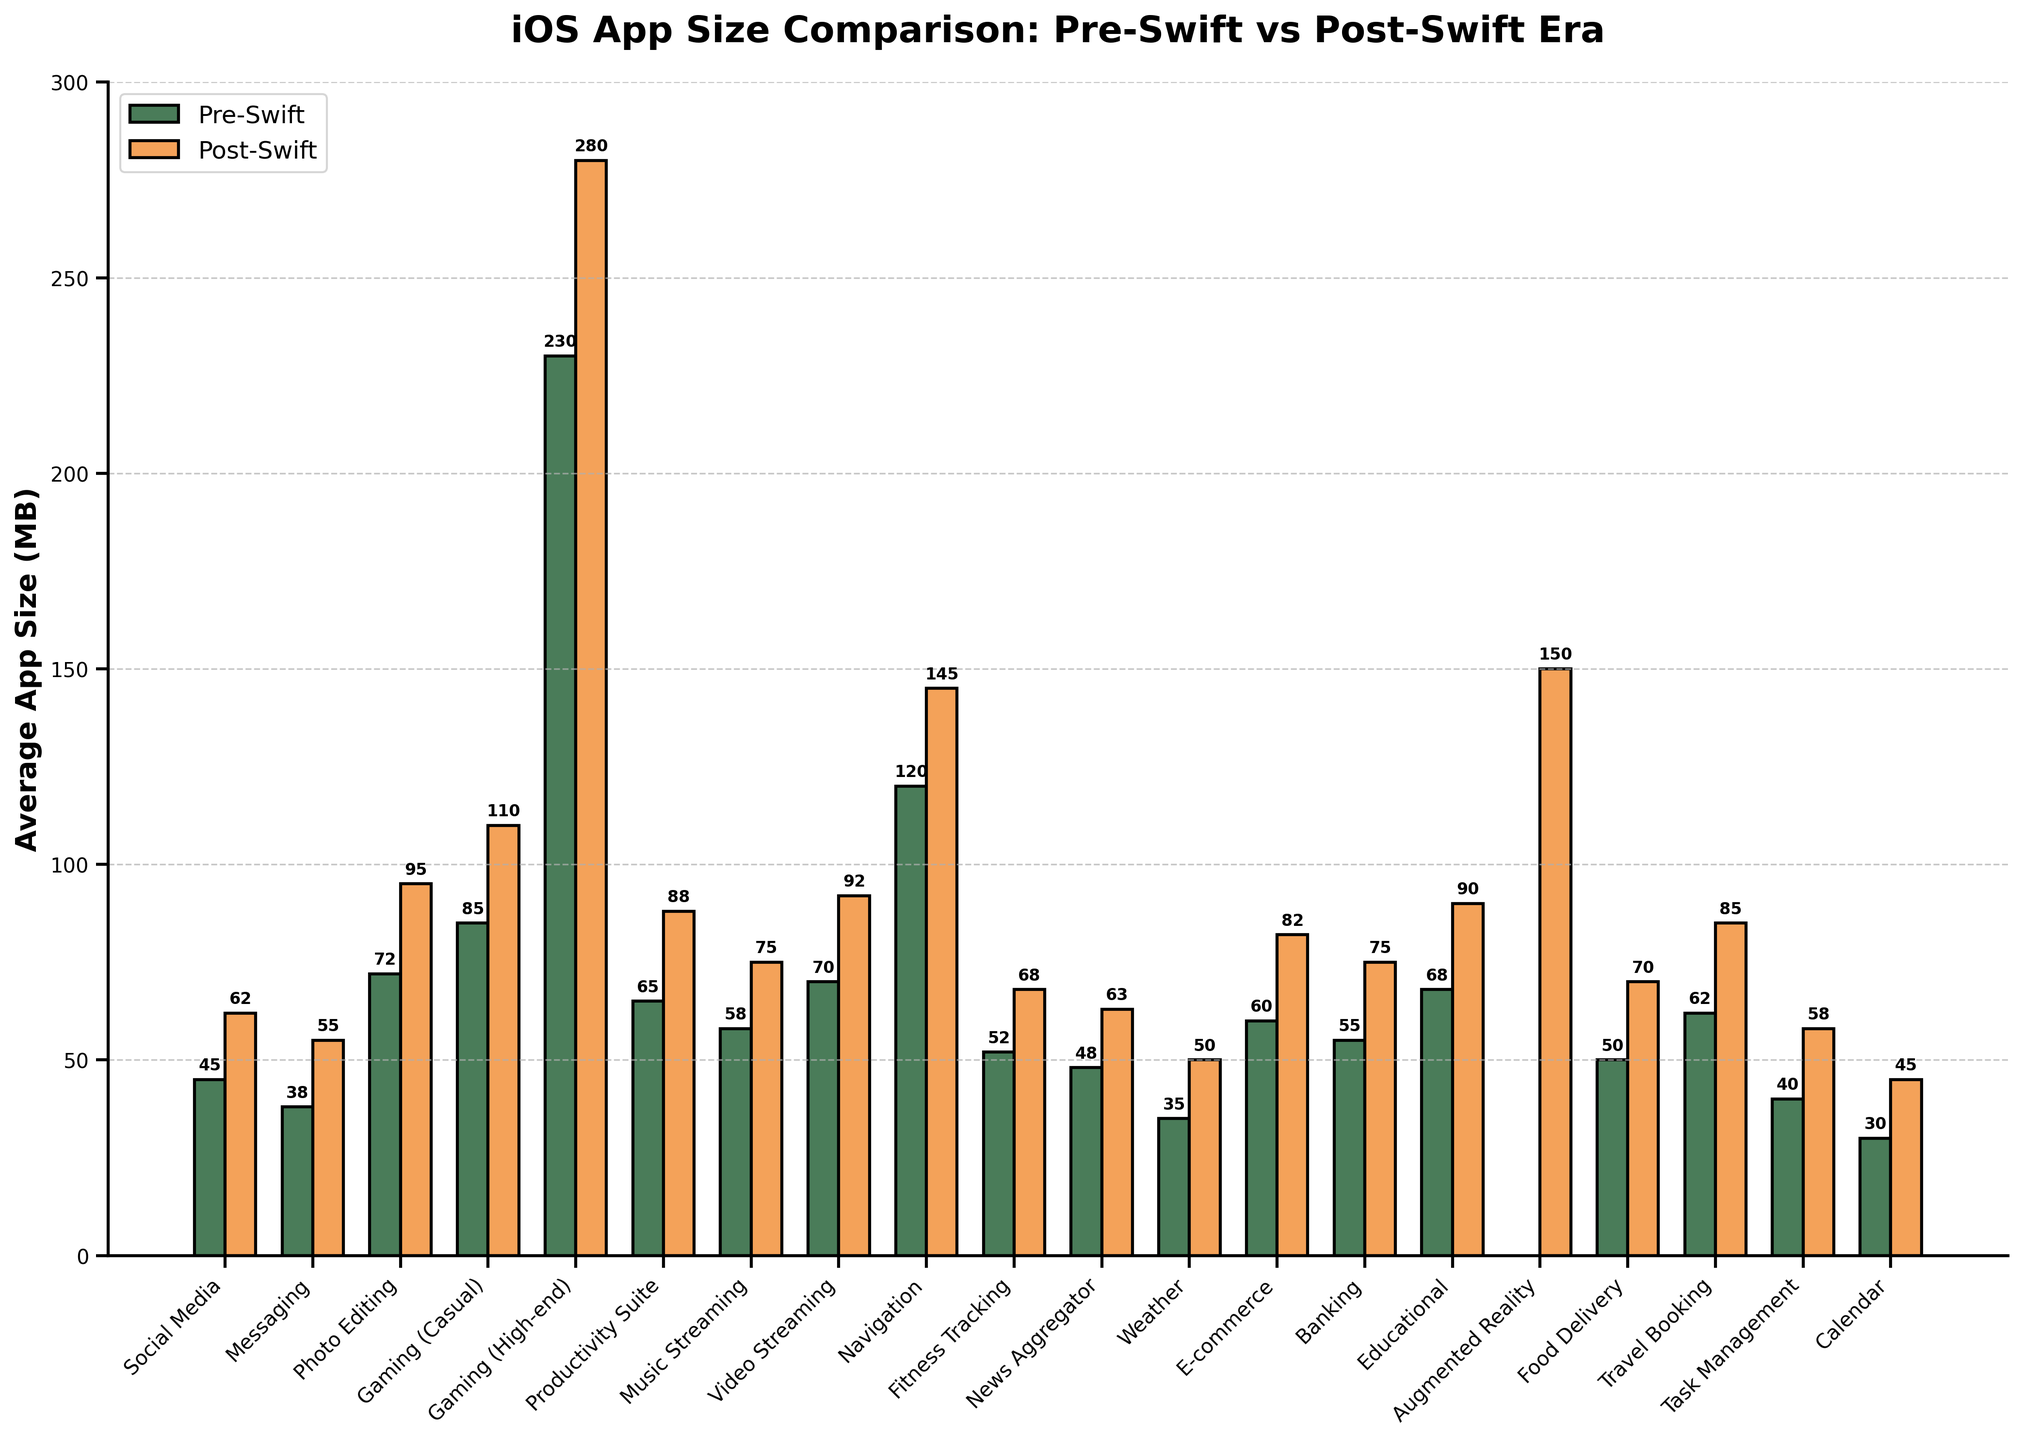What app type saw the largest increase in average size from the pre-Swift to post-Swift era? The bar representing "Gaming (High-end)" shows the highest post-Swift value of 280 MB compared to its pre-Swift value of 230 MB, resulting in an increase of 50 MB.
Answer: Gaming (High-end) Which app type has no data for the pre-Swift era but data for the post-Swift era? The figure shows "N/A" for the pre-Swift era and a value for the post-Swift era for the "Augmented Reality" app type.
Answer: Augmented Reality By how many megabytes did the average app size of Productivity Suite apps increase from pre-Swift to post-Swift? The pre-Swift size for Productivity Suite is 65 MB, and the post-Swift size is 88 MB. The increase is 88 - 65 = 23 MB.
Answer: 23 MB Which app type has the smallest average size in the post-Swift era, and what is that size? Examining the bars, the "Calendar" app has the smallest average size in the post-Swift era at 45 MB.
Answer: Calendar, 45 MB How much larger is the average size of Gaming (Casual) apps compared to Weather apps in the post-Swift era? The post-Swift size of Gaming (Casual) apps is 110 MB, and Weather apps are 50 MB. The difference is 110 - 50 = 60 MB.
Answer: 60 MB Between Navigation and Video Streaming apps, which saw a smaller increase in average size from pre-Swift to post-Swift? Navigation apps increased from 120 MB to 145 MB, a difference of 25 MB. Video Streaming apps increased from 70 MB to 92 MB, a difference of 22 MB. Thus, Video Streaming apps saw a smaller increase.
Answer: Video Streaming What is the average increase in size for Messaging and Social Media apps from pre-Swift to post-Swift? Messaging apps increased from 38 MB to 55 MB (55 - 38 = 17 MB). Social Media apps increased from 45 MB to 62 MB (62 - 45 = 17 MB). The average increase is (17 + 17) / 2 = 17 MB.
Answer: 17 MB Which app type had a post-Swift average size of 75 MB? The "Music Streaming" and "Banking" app types both have bars representing 75 MB in the post-Swift era.
Answer: Music Streaming, Banking What is the combined average size of the largest app types in the pre-Swift era? The largest app type is Gaming (High-end) with 230 MB, the next is Navigation with 120 MB. The combined size is 230 + 120 = 350 MB.
Answer: 350 MB 